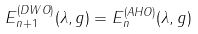<formula> <loc_0><loc_0><loc_500><loc_500>E _ { n + 1 } ^ { ( D W O ) } ( \lambda , g ) = E _ { n } ^ { ( A H O ) } ( \lambda , g )</formula> 